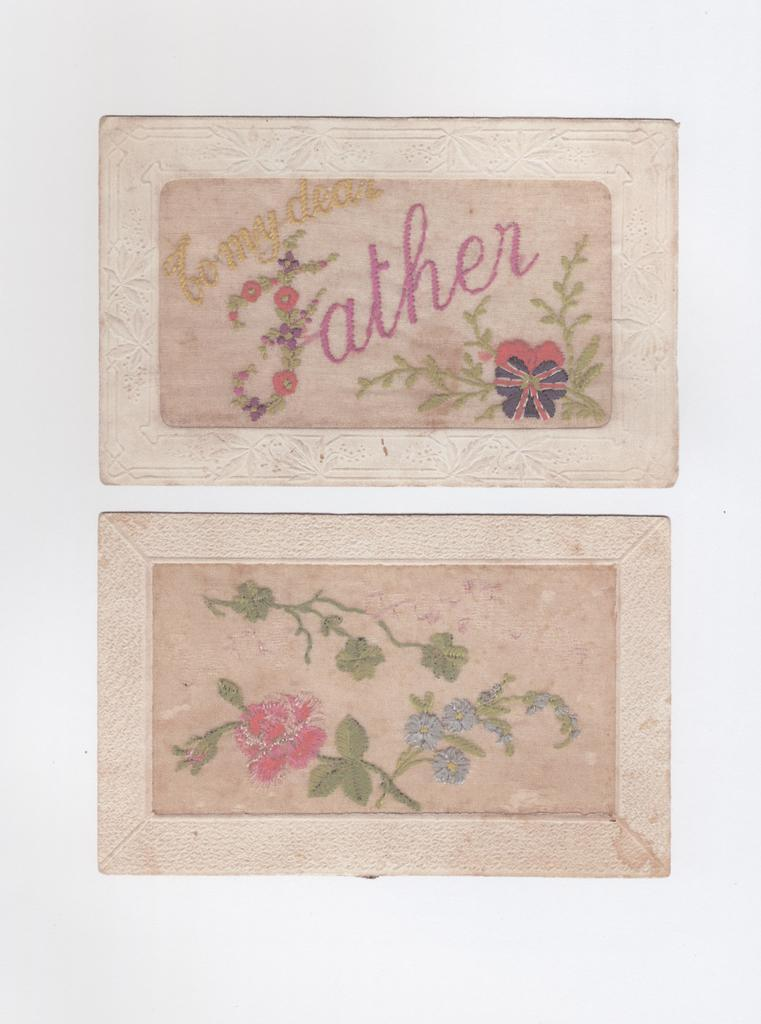How many photo frames are present in the image? There are two photo frames in the image. What can be found inside the photo frames? The photo frames contain images and text. What is the color of the background in the image? The background of the image is white. What type of vegetable is being protested in the image? There is no protest or vegetable present in the image; it features two photo frames with images and text against a white background. 